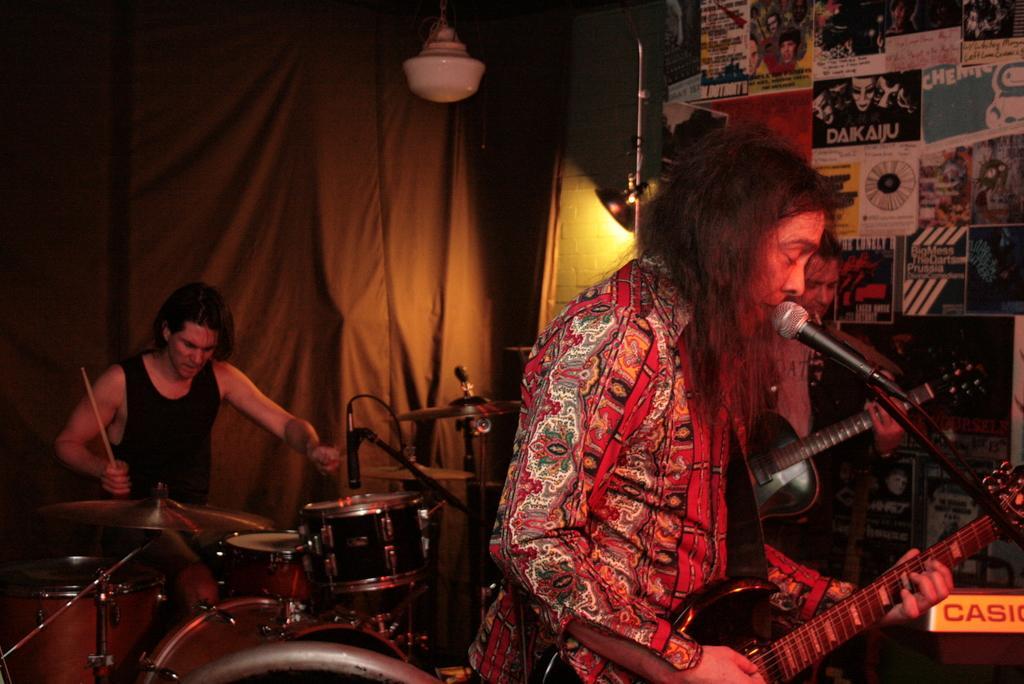Can you describe this image briefly? in this picture we can see a person standing and holding a guitar he singing a song with the help of microphone and decide one more person is standing and he is holding a microphone at the left corner we can see a person stand sitting he is playing a drums 